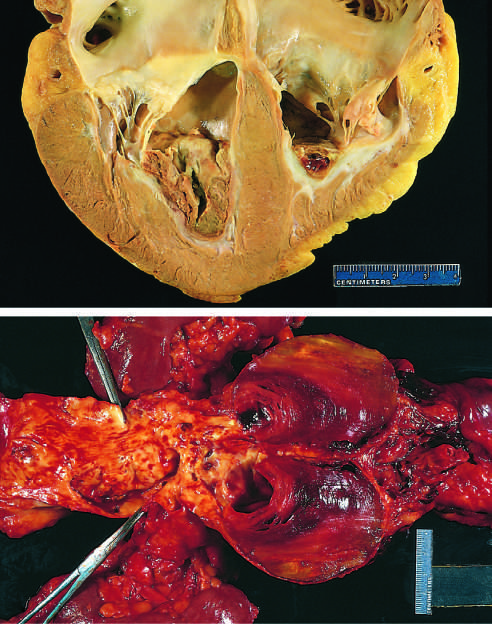what overlies white fibrous scar?
Answer the question using a single word or phrase. Thrombus 